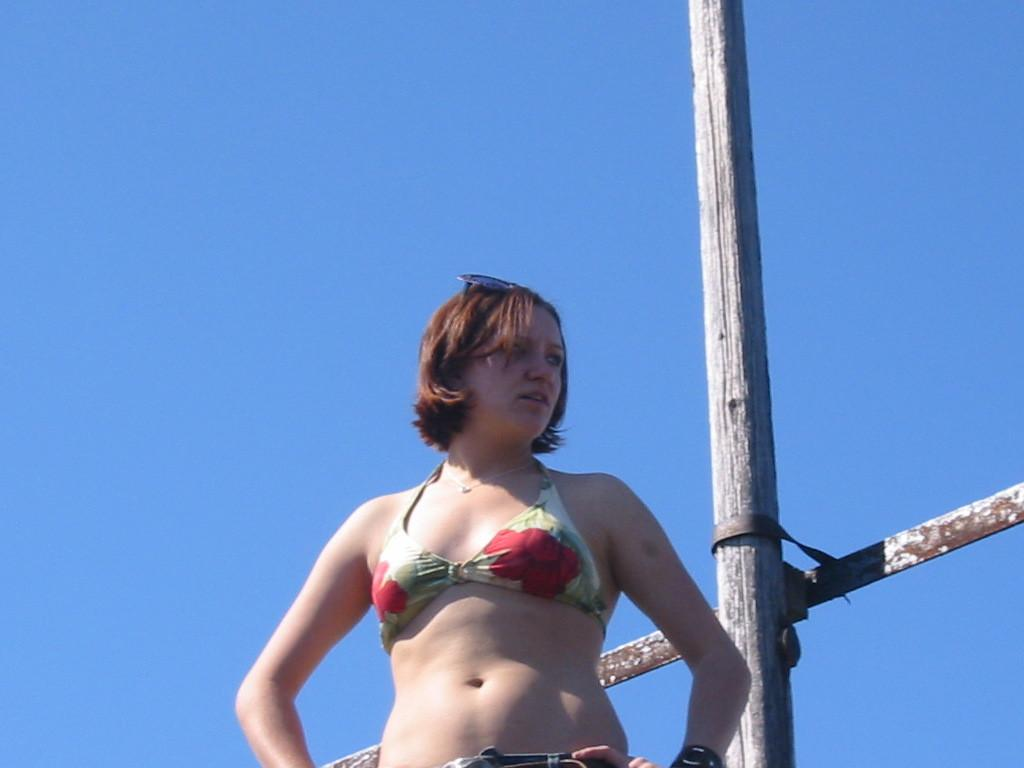What is the main subject in the image? There is a woman standing in the image. What object can be seen besides the woman in the image? There is a wooden pole in the image. What is the color of the sky in the image? The sky is blue in color. What type of company is the woman working for in the image? There is no indication in the image that the woman is working for any company. How does the woman grip the wooden pole in the image? The image does not show the woman gripping the wooden pole, so it cannot be determined from the picture. 